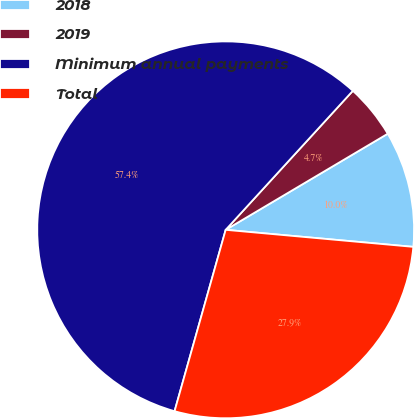Convert chart. <chart><loc_0><loc_0><loc_500><loc_500><pie_chart><fcel>2018<fcel>2019<fcel>Minimum annual payments<fcel>Total<nl><fcel>9.96%<fcel>4.69%<fcel>57.42%<fcel>27.93%<nl></chart> 